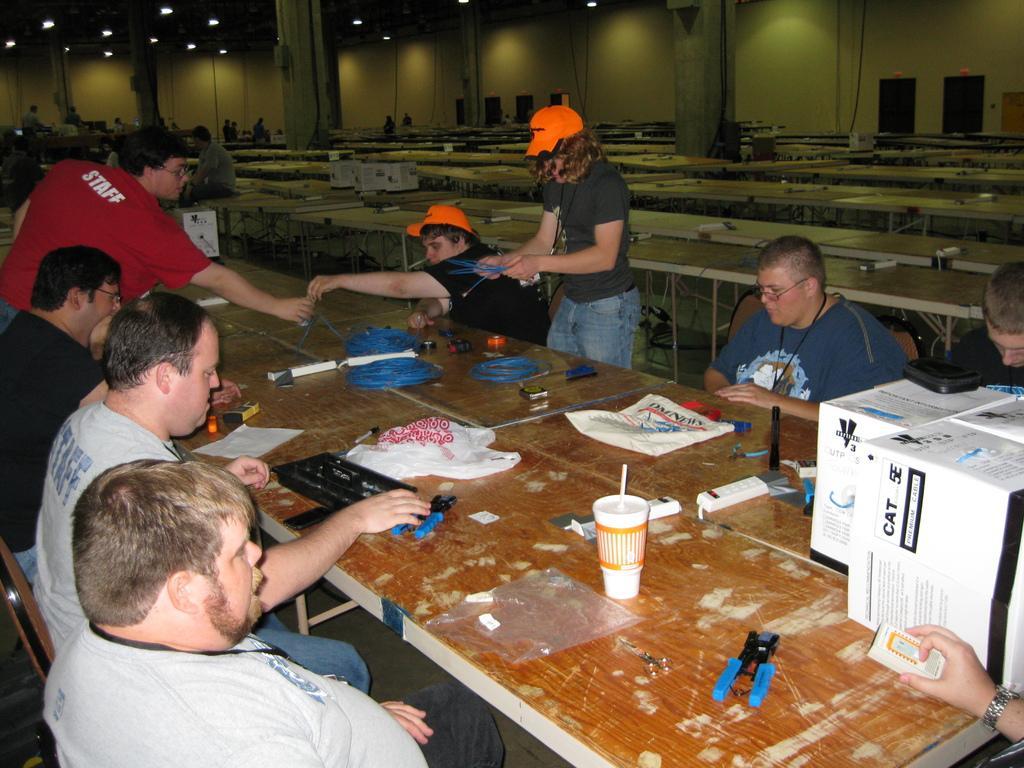How would you summarize this image in a sentence or two? In this image I can see a group of people who are sitting in front of the table on the chair, among them two people are standing. On the right side we have a woman who is wearing a red hat and on the left side we have a man who is wearing a red t-shirt. On the table we have a cup, boxes and few other stuff on it. Behind these people there are some other tables on the floor. 